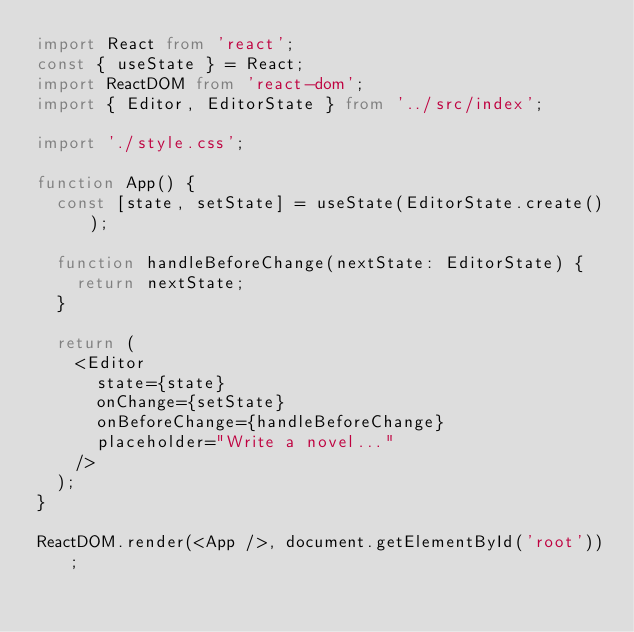<code> <loc_0><loc_0><loc_500><loc_500><_TypeScript_>import React from 'react';
const { useState } = React;
import ReactDOM from 'react-dom';
import { Editor, EditorState } from '../src/index';

import './style.css';

function App() {
  const [state, setState] = useState(EditorState.create());

  function handleBeforeChange(nextState: EditorState) {
    return nextState;
  }

  return (
    <Editor
      state={state}
      onChange={setState}
      onBeforeChange={handleBeforeChange}
      placeholder="Write a novel..."
    />
  );
}

ReactDOM.render(<App />, document.getElementById('root'));
</code> 